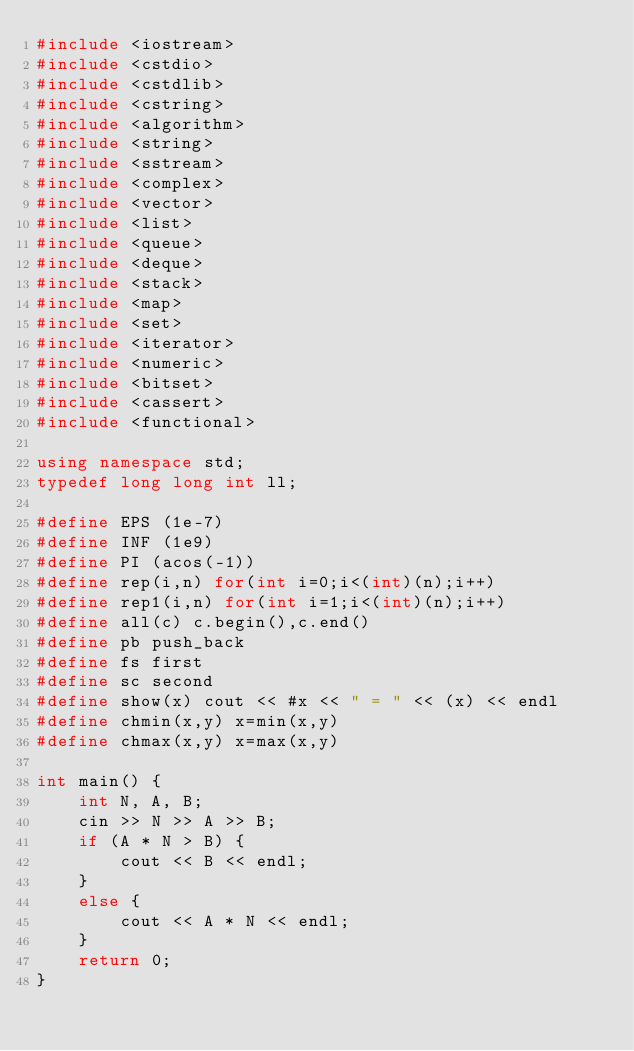<code> <loc_0><loc_0><loc_500><loc_500><_C++_>#include <iostream>
#include <cstdio>
#include <cstdlib>
#include <cstring>
#include <algorithm>
#include <string>
#include <sstream>
#include <complex>
#include <vector>
#include <list>
#include <queue>
#include <deque>
#include <stack>
#include <map>
#include <set>
#include <iterator>
#include <numeric>
#include <bitset>
#include <cassert>
#include <functional>

using namespace std;
typedef long long int ll;

#define EPS (1e-7)
#define INF (1e9)
#define PI (acos(-1))
#define rep(i,n) for(int i=0;i<(int)(n);i++)
#define rep1(i,n) for(int i=1;i<(int)(n);i++)
#define all(c) c.begin(),c.end()
#define pb push_back
#define fs first
#define sc second
#define show(x) cout << #x << " = " << (x) << endl
#define chmin(x,y) x=min(x,y)
#define chmax(x,y) x=max(x,y)

int main() {
	int N, A, B;
	cin >> N >> A >> B;
	if (A * N > B) {
		cout << B << endl;
	}
	else {
		cout << A * N << endl;
	}
	return 0;
}</code> 